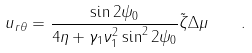Convert formula to latex. <formula><loc_0><loc_0><loc_500><loc_500>u _ { r \theta } = \frac { \sin 2 \psi _ { 0 } } { 4 \eta + \gamma _ { 1 } \nu _ { 1 } ^ { 2 } \sin ^ { 2 } 2 \psi _ { 0 } } \tilde { \zeta } \Delta \mu \quad .</formula> 